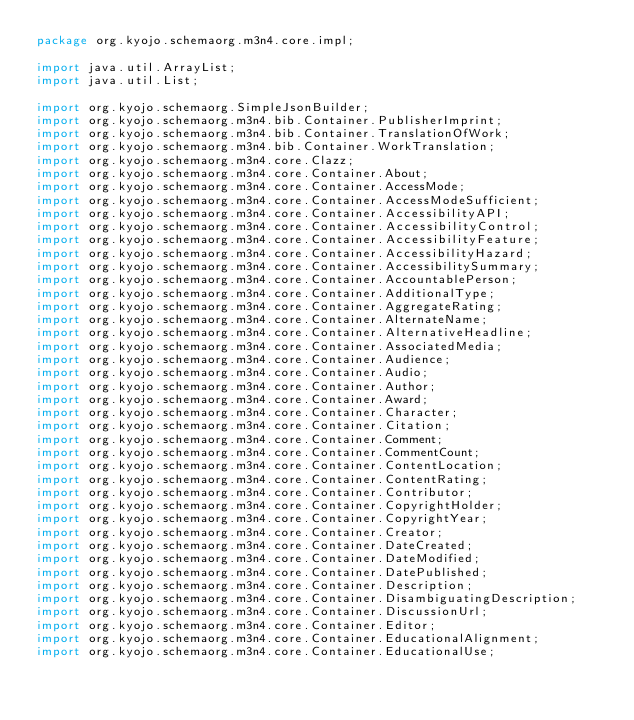Convert code to text. <code><loc_0><loc_0><loc_500><loc_500><_Java_>package org.kyojo.schemaorg.m3n4.core.impl;

import java.util.ArrayList;
import java.util.List;

import org.kyojo.schemaorg.SimpleJsonBuilder;
import org.kyojo.schemaorg.m3n4.bib.Container.PublisherImprint;
import org.kyojo.schemaorg.m3n4.bib.Container.TranslationOfWork;
import org.kyojo.schemaorg.m3n4.bib.Container.WorkTranslation;
import org.kyojo.schemaorg.m3n4.core.Clazz;
import org.kyojo.schemaorg.m3n4.core.Container.About;
import org.kyojo.schemaorg.m3n4.core.Container.AccessMode;
import org.kyojo.schemaorg.m3n4.core.Container.AccessModeSufficient;
import org.kyojo.schemaorg.m3n4.core.Container.AccessibilityAPI;
import org.kyojo.schemaorg.m3n4.core.Container.AccessibilityControl;
import org.kyojo.schemaorg.m3n4.core.Container.AccessibilityFeature;
import org.kyojo.schemaorg.m3n4.core.Container.AccessibilityHazard;
import org.kyojo.schemaorg.m3n4.core.Container.AccessibilitySummary;
import org.kyojo.schemaorg.m3n4.core.Container.AccountablePerson;
import org.kyojo.schemaorg.m3n4.core.Container.AdditionalType;
import org.kyojo.schemaorg.m3n4.core.Container.AggregateRating;
import org.kyojo.schemaorg.m3n4.core.Container.AlternateName;
import org.kyojo.schemaorg.m3n4.core.Container.AlternativeHeadline;
import org.kyojo.schemaorg.m3n4.core.Container.AssociatedMedia;
import org.kyojo.schemaorg.m3n4.core.Container.Audience;
import org.kyojo.schemaorg.m3n4.core.Container.Audio;
import org.kyojo.schemaorg.m3n4.core.Container.Author;
import org.kyojo.schemaorg.m3n4.core.Container.Award;
import org.kyojo.schemaorg.m3n4.core.Container.Character;
import org.kyojo.schemaorg.m3n4.core.Container.Citation;
import org.kyojo.schemaorg.m3n4.core.Container.Comment;
import org.kyojo.schemaorg.m3n4.core.Container.CommentCount;
import org.kyojo.schemaorg.m3n4.core.Container.ContentLocation;
import org.kyojo.schemaorg.m3n4.core.Container.ContentRating;
import org.kyojo.schemaorg.m3n4.core.Container.Contributor;
import org.kyojo.schemaorg.m3n4.core.Container.CopyrightHolder;
import org.kyojo.schemaorg.m3n4.core.Container.CopyrightYear;
import org.kyojo.schemaorg.m3n4.core.Container.Creator;
import org.kyojo.schemaorg.m3n4.core.Container.DateCreated;
import org.kyojo.schemaorg.m3n4.core.Container.DateModified;
import org.kyojo.schemaorg.m3n4.core.Container.DatePublished;
import org.kyojo.schemaorg.m3n4.core.Container.Description;
import org.kyojo.schemaorg.m3n4.core.Container.DisambiguatingDescription;
import org.kyojo.schemaorg.m3n4.core.Container.DiscussionUrl;
import org.kyojo.schemaorg.m3n4.core.Container.Editor;
import org.kyojo.schemaorg.m3n4.core.Container.EducationalAlignment;
import org.kyojo.schemaorg.m3n4.core.Container.EducationalUse;</code> 